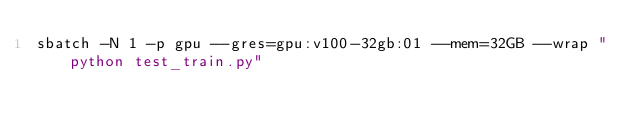<code> <loc_0><loc_0><loc_500><loc_500><_Bash_>sbatch -N 1 -p gpu --gres=gpu:v100-32gb:01 --mem=32GB --wrap "python test_train.py"
</code> 